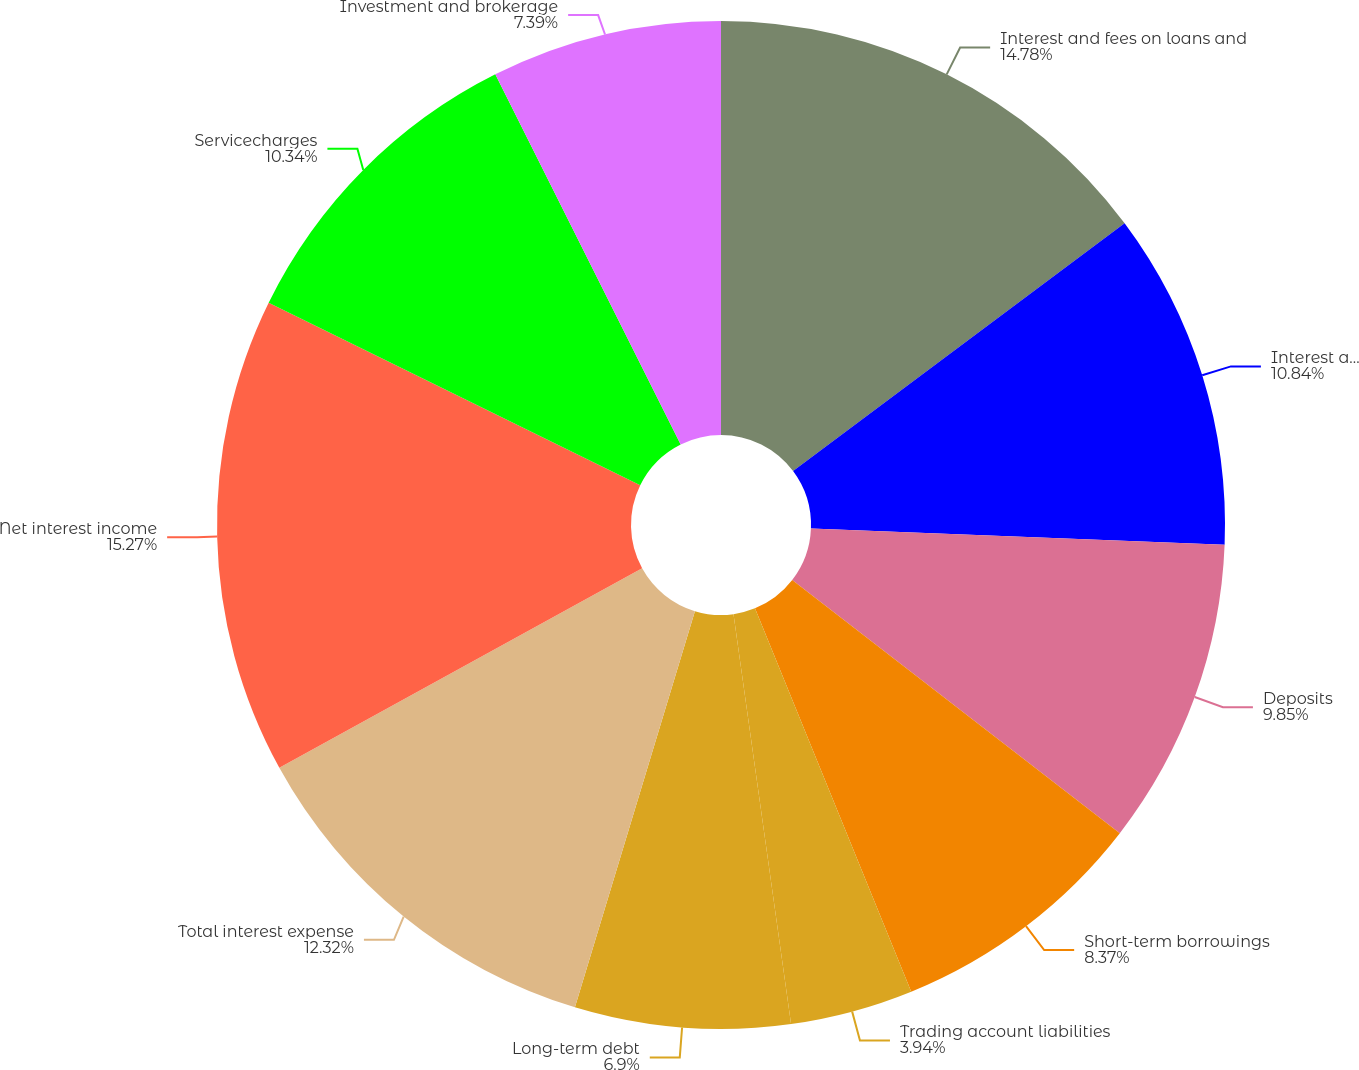<chart> <loc_0><loc_0><loc_500><loc_500><pie_chart><fcel>Interest and fees on loans and<fcel>Interest and dividends on<fcel>Deposits<fcel>Short-term borrowings<fcel>Trading account liabilities<fcel>Long-term debt<fcel>Total interest expense<fcel>Net interest income<fcel>Servicecharges<fcel>Investment and brokerage<nl><fcel>14.78%<fcel>10.84%<fcel>9.85%<fcel>8.37%<fcel>3.94%<fcel>6.9%<fcel>12.32%<fcel>15.27%<fcel>10.34%<fcel>7.39%<nl></chart> 